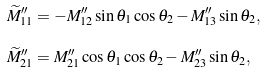<formula> <loc_0><loc_0><loc_500><loc_500>\widetilde { M } ^ { \prime \prime } _ { 1 1 } & = - M ^ { \prime \prime } _ { 1 2 } \sin \theta _ { 1 } \cos \theta _ { 2 } - M ^ { \prime \prime } _ { 1 3 } \sin \theta _ { 2 } , \\ \widetilde { M } ^ { \prime \prime } _ { 2 1 } & = M ^ { \prime \prime } _ { 2 1 } \cos \theta _ { 1 } \cos \theta _ { 2 } - M ^ { \prime \prime } _ { 2 3 } \sin \theta _ { 2 } ,</formula> 